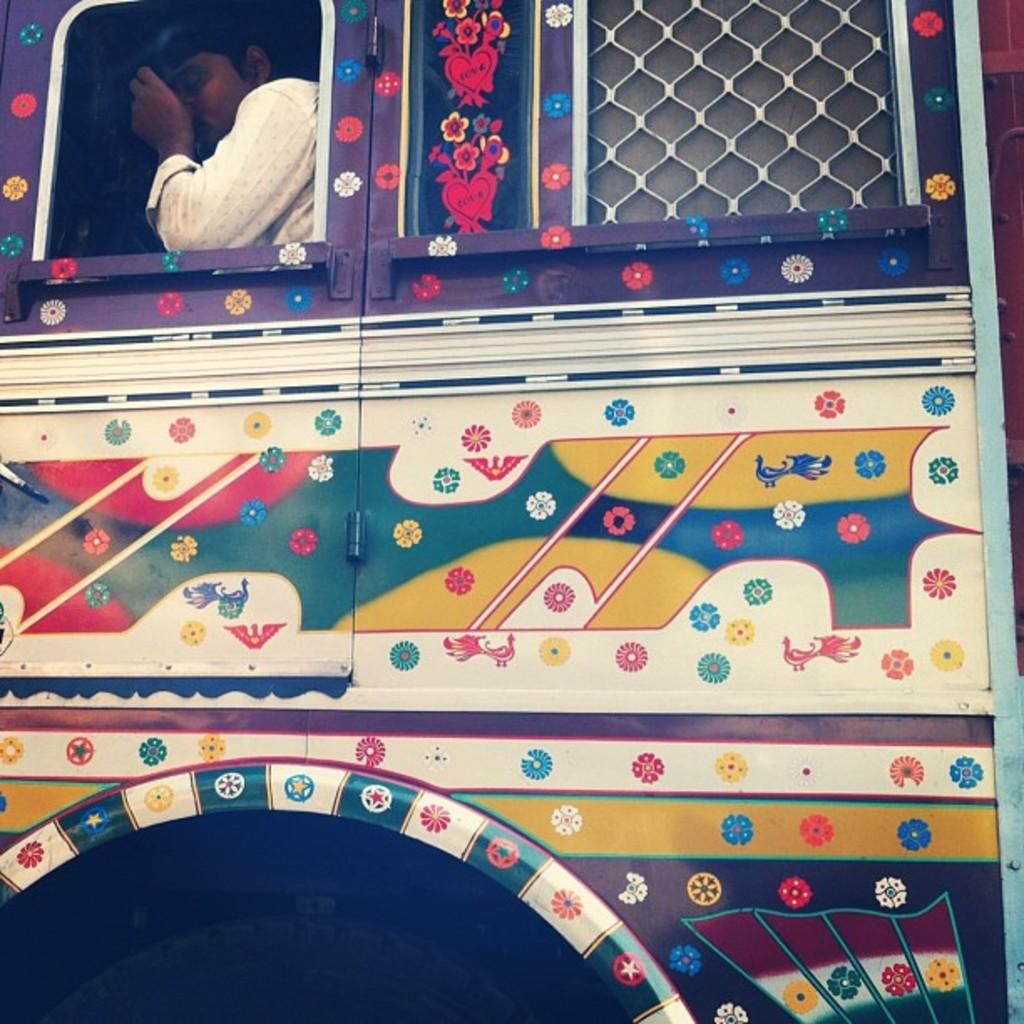Who or what is present in the image? There is a person in the image. What is the person doing or where are they located? The person is in a vehicle. What type of box is the person holding in the image? There is no box present in the image; the person is in a vehicle. 